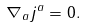<formula> <loc_0><loc_0><loc_500><loc_500>\nabla _ { a } j ^ { a } = 0 .</formula> 